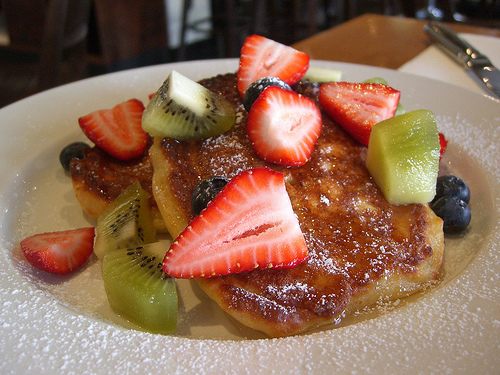<image>
Can you confirm if the strawberry is above the kiwi? Yes. The strawberry is positioned above the kiwi in the vertical space, higher up in the scene. 